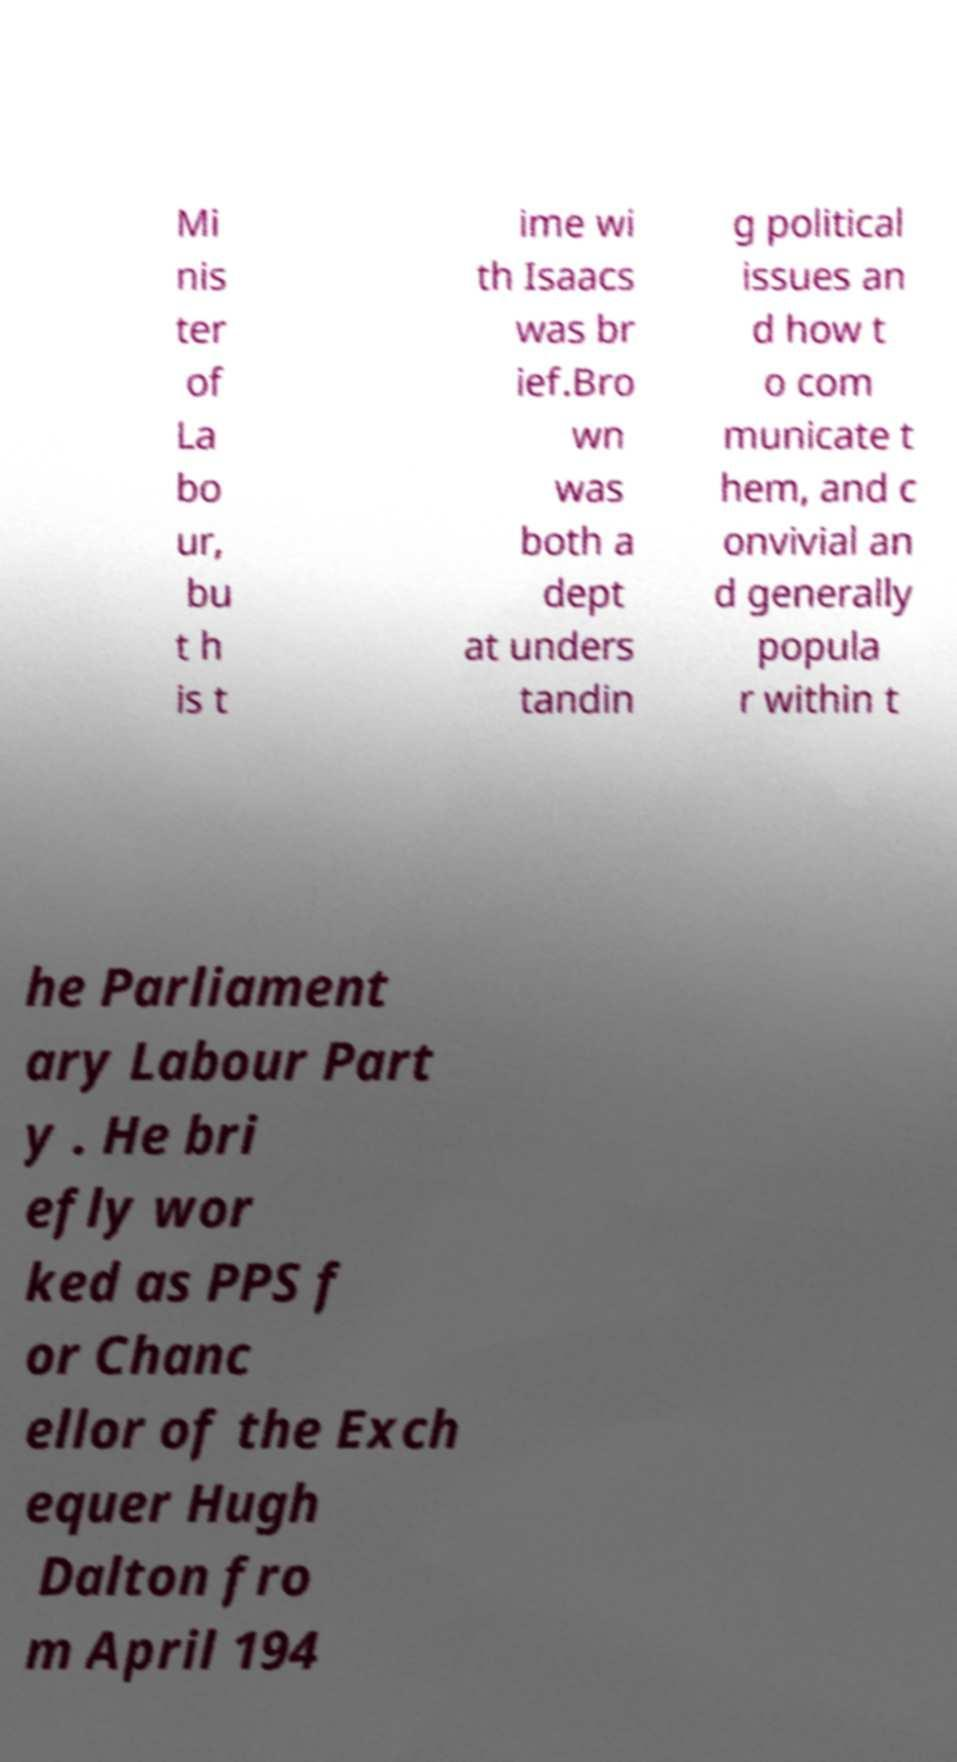What messages or text are displayed in this image? I need them in a readable, typed format. Mi nis ter of La bo ur, bu t h is t ime wi th Isaacs was br ief.Bro wn was both a dept at unders tandin g political issues an d how t o com municate t hem, and c onvivial an d generally popula r within t he Parliament ary Labour Part y . He bri efly wor ked as PPS f or Chanc ellor of the Exch equer Hugh Dalton fro m April 194 